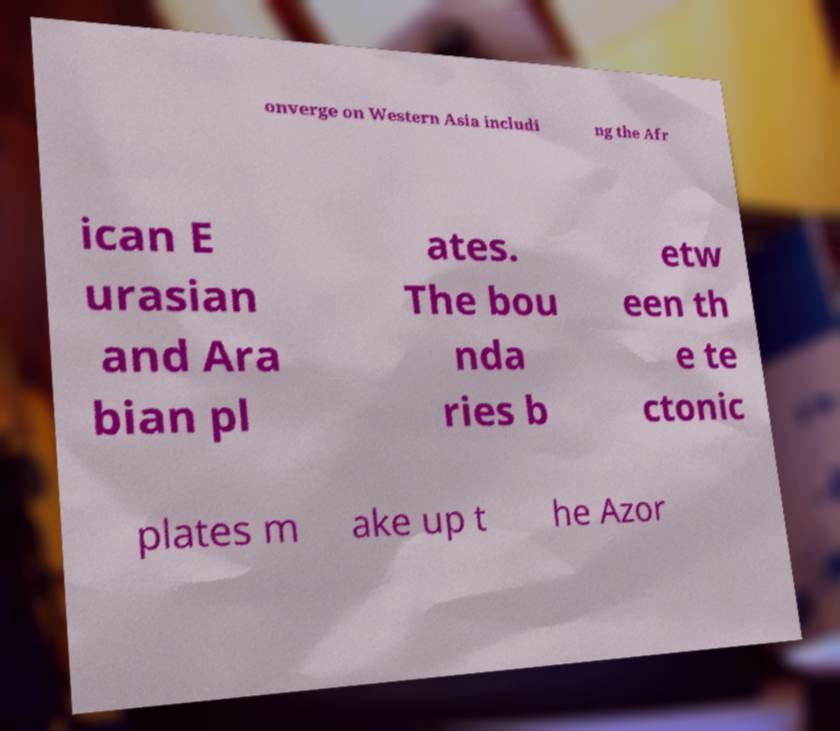For documentation purposes, I need the text within this image transcribed. Could you provide that? onverge on Western Asia includi ng the Afr ican E urasian and Ara bian pl ates. The bou nda ries b etw een th e te ctonic plates m ake up t he Azor 